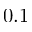Convert formula to latex. <formula><loc_0><loc_0><loc_500><loc_500>0 . 1</formula> 